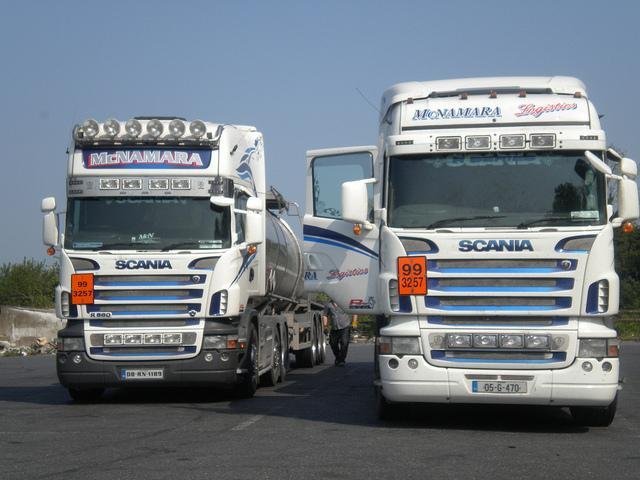What business are these vehicles in? Please explain your reasoning. logistics. That is the business the trucks run. 